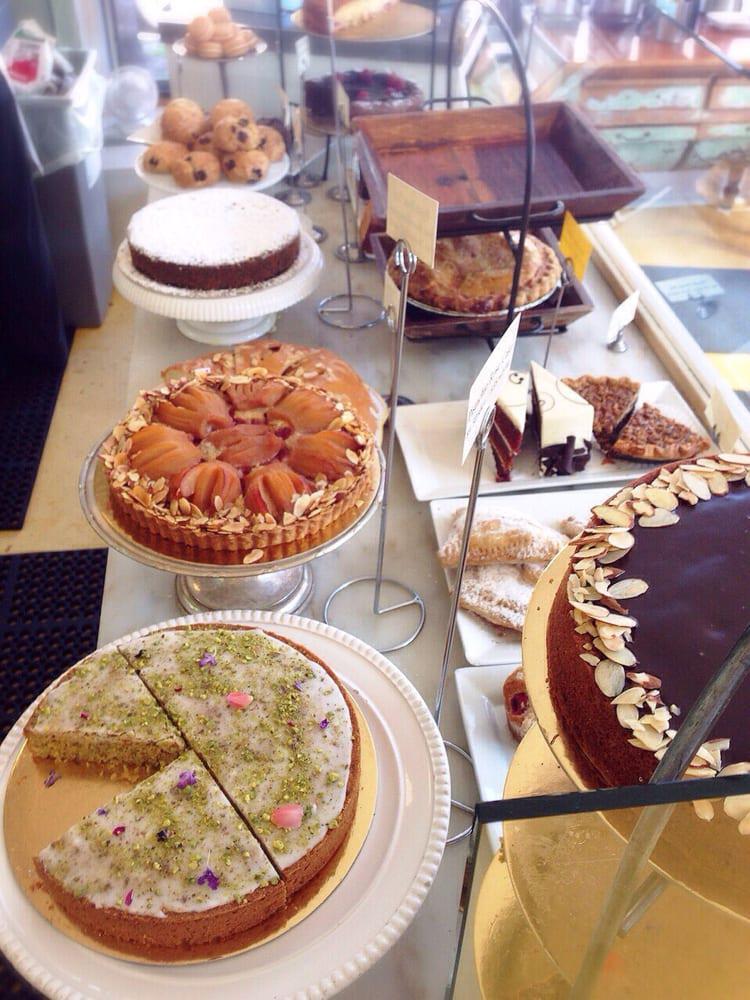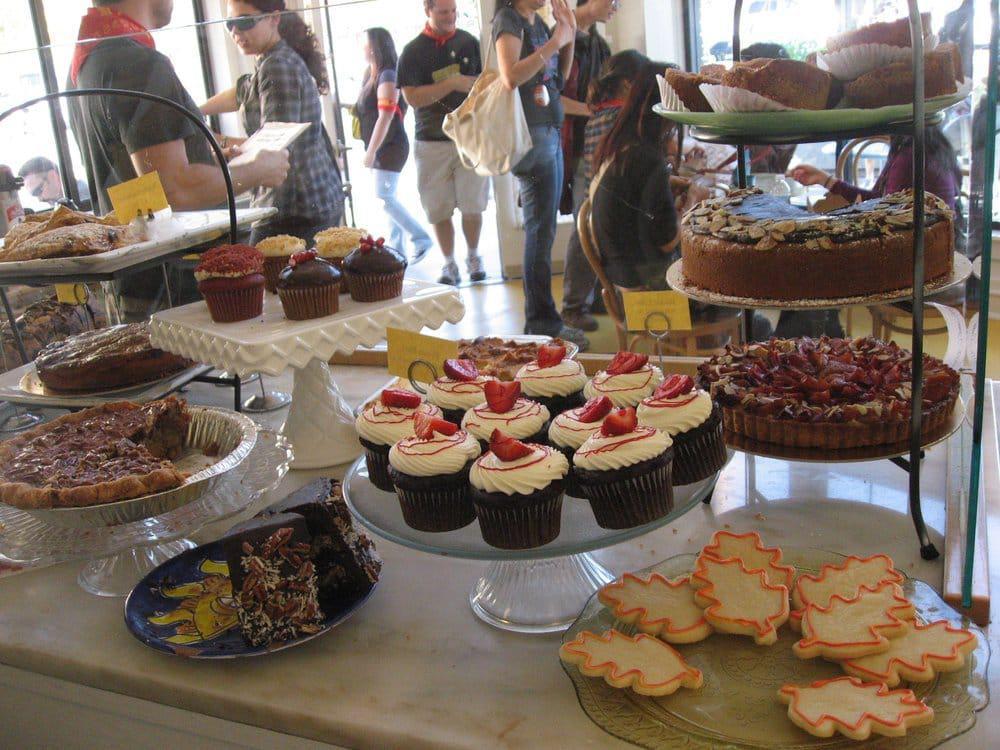The first image is the image on the left, the second image is the image on the right. Analyze the images presented: Is the assertion "Pastries have yellow labels in one of the images." valid? Answer yes or no. Yes. The first image is the image on the left, the second image is the image on the right. Evaluate the accuracy of this statement regarding the images: "There are a multiple baked goods per image, exposed to open air.". Is it true? Answer yes or no. Yes. 